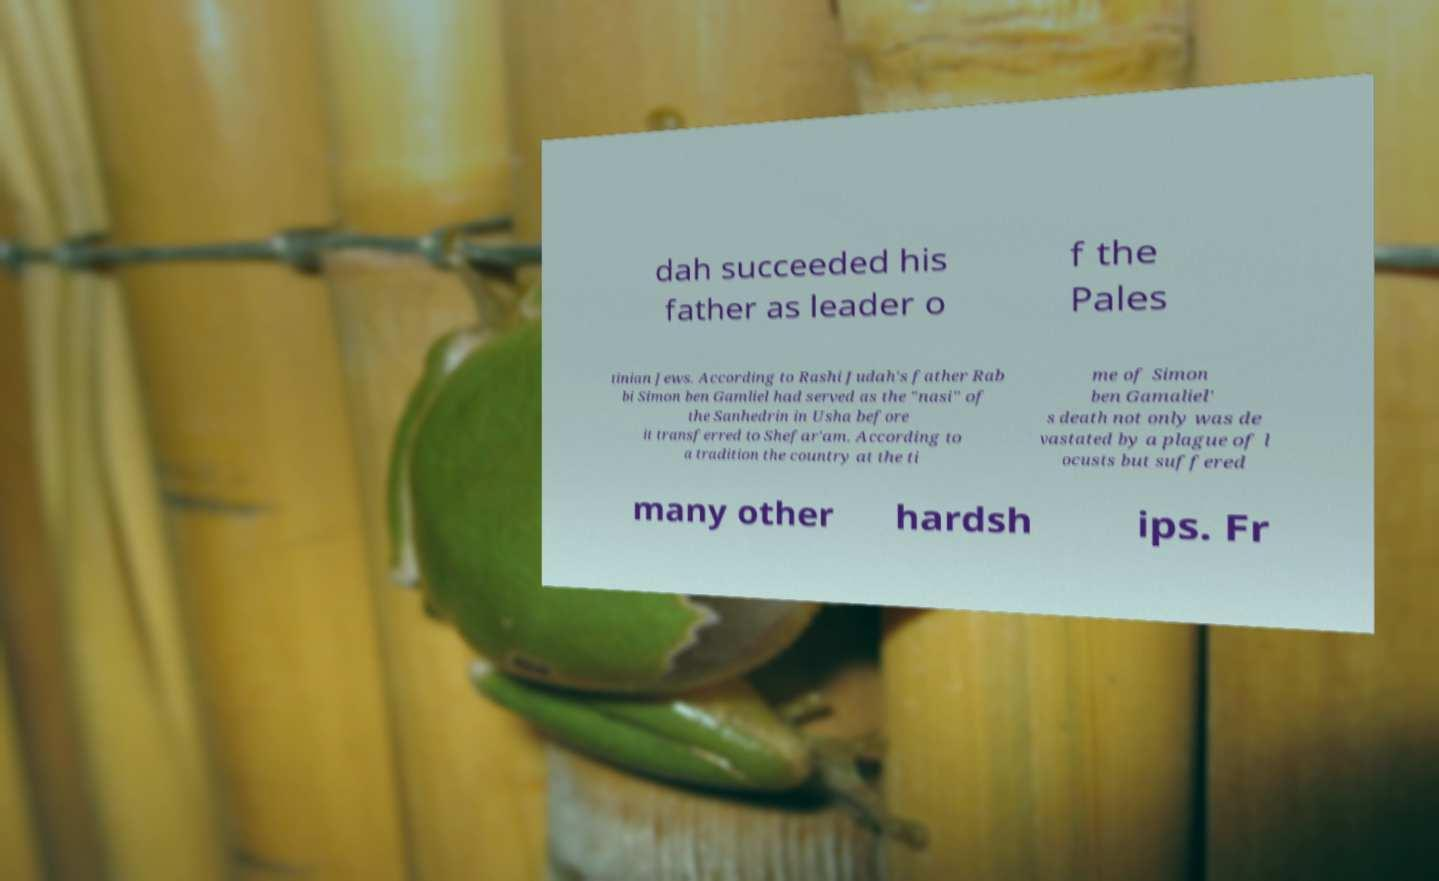Can you read and provide the text displayed in the image?This photo seems to have some interesting text. Can you extract and type it out for me? dah succeeded his father as leader o f the Pales tinian Jews. According to Rashi Judah's father Rab bi Simon ben Gamliel had served as the "nasi" of the Sanhedrin in Usha before it transferred to Shefar'am. According to a tradition the country at the ti me of Simon ben Gamaliel' s death not only was de vastated by a plague of l ocusts but suffered many other hardsh ips. Fr 